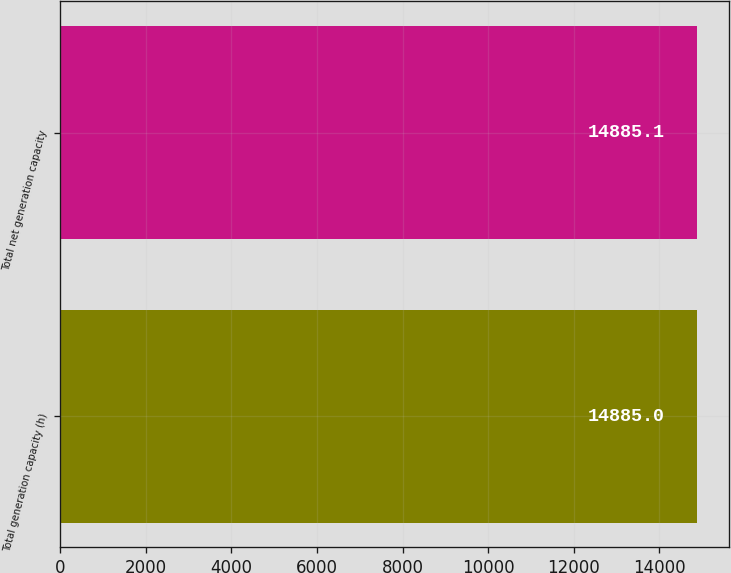Convert chart. <chart><loc_0><loc_0><loc_500><loc_500><bar_chart><fcel>Total generation capacity (h)<fcel>Total net generation capacity<nl><fcel>14885<fcel>14885.1<nl></chart> 